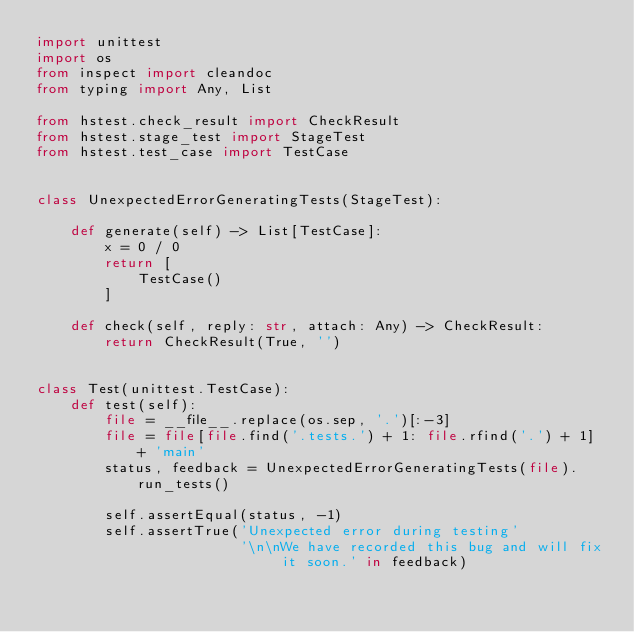<code> <loc_0><loc_0><loc_500><loc_500><_Python_>import unittest
import os
from inspect import cleandoc
from typing import Any, List

from hstest.check_result import CheckResult
from hstest.stage_test import StageTest
from hstest.test_case import TestCase


class UnexpectedErrorGeneratingTests(StageTest):

    def generate(self) -> List[TestCase]:
        x = 0 / 0
        return [
            TestCase()
        ]

    def check(self, reply: str, attach: Any) -> CheckResult:
        return CheckResult(True, '')


class Test(unittest.TestCase):
    def test(self):
        file = __file__.replace(os.sep, '.')[:-3]
        file = file[file.find('.tests.') + 1: file.rfind('.') + 1] + 'main'
        status, feedback = UnexpectedErrorGeneratingTests(file).run_tests()

        self.assertEqual(status, -1)
        self.assertTrue('Unexpected error during testing'
                        '\n\nWe have recorded this bug and will fix it soon.' in feedback)
</code> 